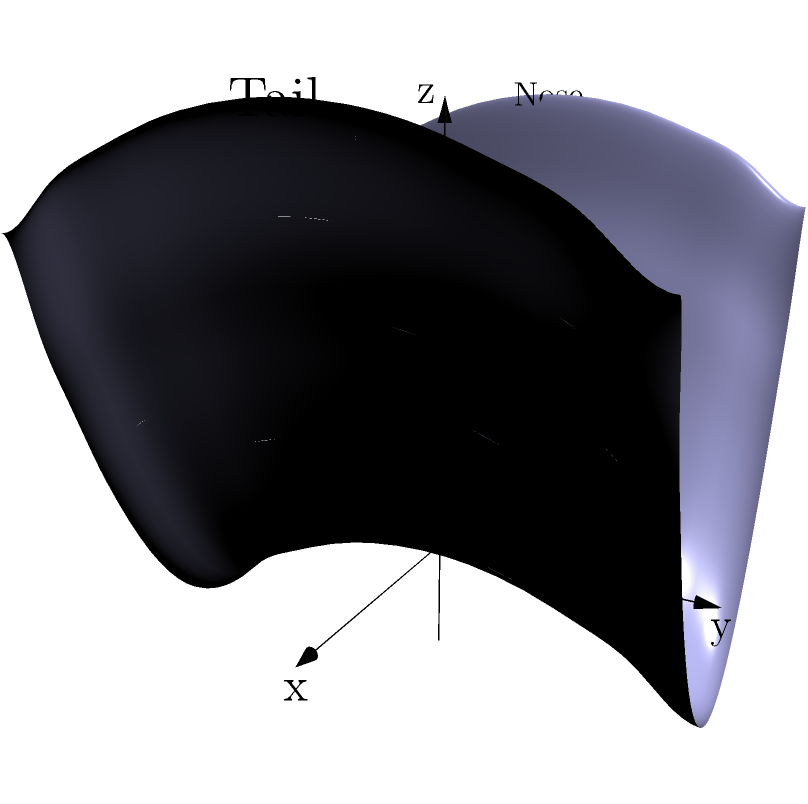In the 3D coordinate system shown above, a surfboard's curvature is represented by the function $z = 0.05(x^2 - y^2)$. What shape does this function create, and how does it relate to the surfboard's design? To understand the shape and its relation to the surfboard's design, let's break it down step-by-step:

1. The function $z = 0.05(x^2 - y^2)$ is a quadratic surface known as a hyperbolic paraboloid.

2. Along the x-axis (from nose to tail):
   - When $y = 0$, the function becomes $z = 0.05x^2$, which is a parabola curving upward.
   - This represents the rocker of the surfboard, with the nose and tail curved upward.

3. Along the y-axis (from rail to rail):
   - When $x = 0$, the function becomes $z = -0.05y^2$, which is a parabola curving downward.
   - This represents the rail-to-rail curvature, with the center being higher than the edges.

4. The combination of these curves creates a subtle "saddle" shape:
   - The middle of the board is lower than the nose and tail.
   - The center line of the board is higher than the rails.

5. This shape is crucial for surfboard performance:
   - The rocker (curve from nose to tail) helps with maneuverability and prevents nose-diving.
   - The rail-to-rail curvature aids in turning and provides stability.

The 0.05 coefficient determines the intensity of the curvature. A larger number would create more pronounced curves, while a smaller number would result in a flatter board.
Answer: Hyperbolic paraboloid; saddle shape combining upward nose-to-tail rocker and downward rail-to-rail curvature for maneuverability and stability. 